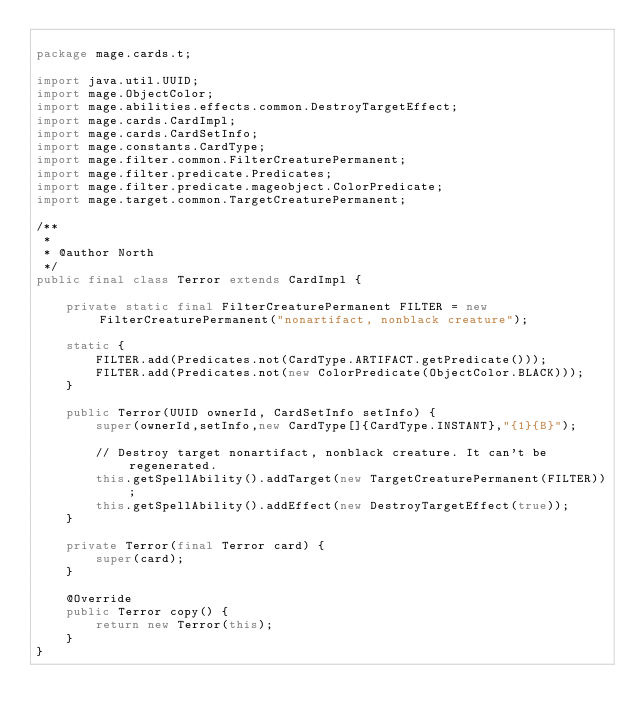Convert code to text. <code><loc_0><loc_0><loc_500><loc_500><_Java_>
package mage.cards.t;

import java.util.UUID;
import mage.ObjectColor;
import mage.abilities.effects.common.DestroyTargetEffect;
import mage.cards.CardImpl;
import mage.cards.CardSetInfo;
import mage.constants.CardType;
import mage.filter.common.FilterCreaturePermanent;
import mage.filter.predicate.Predicates;
import mage.filter.predicate.mageobject.ColorPredicate;
import mage.target.common.TargetCreaturePermanent;

/**
 *
 * @author North
 */
public final class Terror extends CardImpl {

    private static final FilterCreaturePermanent FILTER = new FilterCreaturePermanent("nonartifact, nonblack creature");

    static {
        FILTER.add(Predicates.not(CardType.ARTIFACT.getPredicate()));
        FILTER.add(Predicates.not(new ColorPredicate(ObjectColor.BLACK)));
    }

    public Terror(UUID ownerId, CardSetInfo setInfo) {
        super(ownerId,setInfo,new CardType[]{CardType.INSTANT},"{1}{B}");

        // Destroy target nonartifact, nonblack creature. It can't be regenerated.
        this.getSpellAbility().addTarget(new TargetCreaturePermanent(FILTER));
        this.getSpellAbility().addEffect(new DestroyTargetEffect(true));
    }

    private Terror(final Terror card) {
        super(card);
    }

    @Override
    public Terror copy() {
        return new Terror(this);
    }
}
</code> 